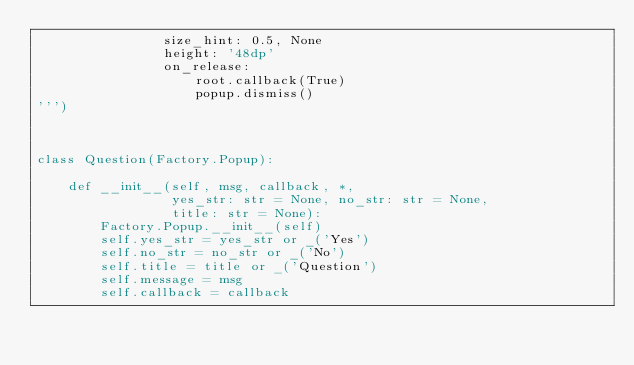<code> <loc_0><loc_0><loc_500><loc_500><_Python_>                size_hint: 0.5, None
                height: '48dp'
                on_release:
                    root.callback(True)
                    popup.dismiss()
''')



class Question(Factory.Popup):

    def __init__(self, msg, callback, *,
                 yes_str: str = None, no_str: str = None,
                 title: str = None):
        Factory.Popup.__init__(self)
        self.yes_str = yes_str or _('Yes')
        self.no_str = no_str or _('No')
        self.title = title or _('Question')
        self.message = msg
        self.callback = callback
</code> 